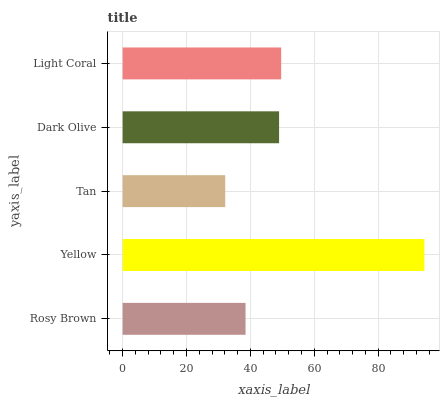Is Tan the minimum?
Answer yes or no. Yes. Is Yellow the maximum?
Answer yes or no. Yes. Is Yellow the minimum?
Answer yes or no. No. Is Tan the maximum?
Answer yes or no. No. Is Yellow greater than Tan?
Answer yes or no. Yes. Is Tan less than Yellow?
Answer yes or no. Yes. Is Tan greater than Yellow?
Answer yes or no. No. Is Yellow less than Tan?
Answer yes or no. No. Is Dark Olive the high median?
Answer yes or no. Yes. Is Dark Olive the low median?
Answer yes or no. Yes. Is Light Coral the high median?
Answer yes or no. No. Is Yellow the low median?
Answer yes or no. No. 